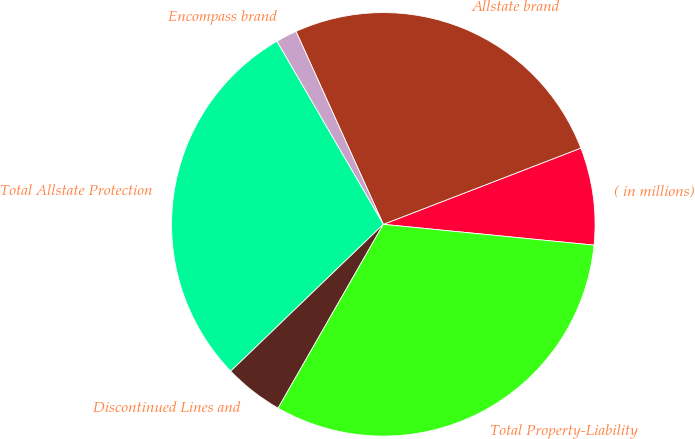Convert chart. <chart><loc_0><loc_0><loc_500><loc_500><pie_chart><fcel>( in millions)<fcel>Allstate brand<fcel>Encompass brand<fcel>Total Allstate Protection<fcel>Discontinued Lines and<fcel>Total Property-Liability<nl><fcel>7.43%<fcel>25.9%<fcel>1.62%<fcel>28.81%<fcel>4.53%<fcel>31.71%<nl></chart> 